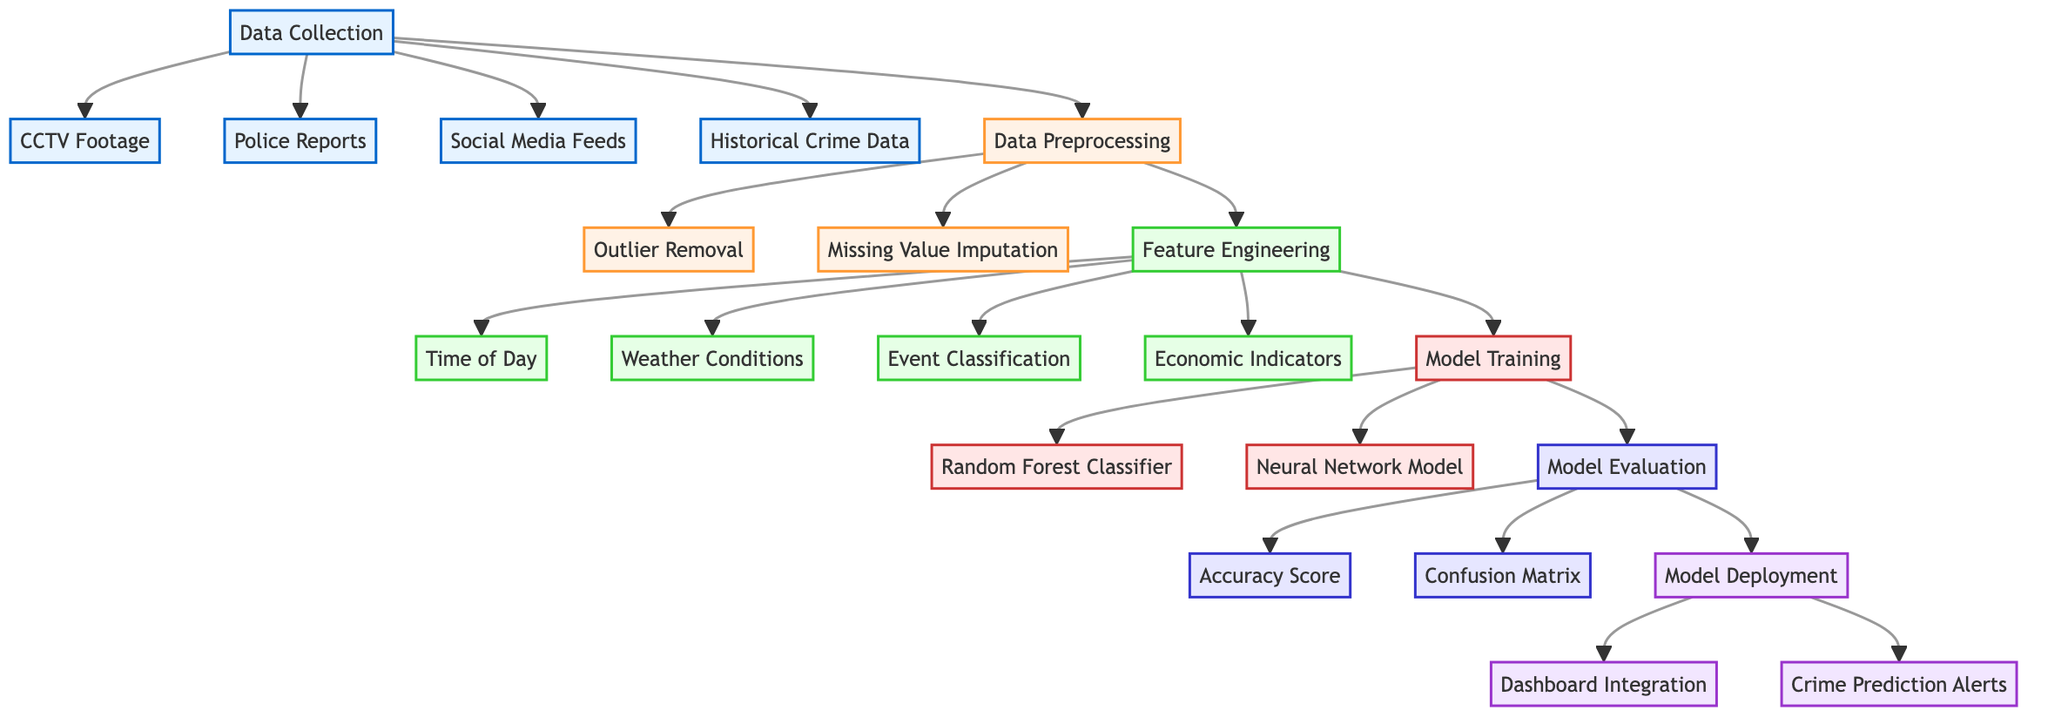What's the first node in the diagram? The diagram begins with the "Data Collection" node, which serves as the starting point for the entire process of predictive analysis.
Answer: Data Collection How many types of data are collected? There are four types of data being collected: CCTV Footage, Police Reports, Social Media Feeds, and Historical Crime Data. This information can be derived from the connections stemming from the "Data Collection" node.
Answer: Four What follows the "Data Preprocessing" node? The next steps after "Data Preprocessing" involve "Feature Engineering," which is the subsequent node connected directly to it, indicating that feature extraction comes after preprocessing.
Answer: Feature Engineering Which models are used for training? The diagram indicates that two models are being used for training: "Random Forest Classifier" and "Neural Network Model," as shown in the branching from the "Model Training" node.
Answer: Random Forest Classifier and Neural Network Model What type of alerts are generated after model deployment? The "Crime Prediction Alerts" node shows the output of this phase, indicating that alerts will be generated to inform residents about potential crimes based on the analysis.
Answer: Crime Prediction Alerts What is the purpose of the "Feature Engineering" step? "Feature Engineering" encompasses the process of creating new features from the existing data, such as time of day, weather conditions, and event classification, which are vital for enhancing the model's predictive capabilities.
Answer: Enhance predictive capabilities How many evaluation metrics are mentioned in the diagram? There are two evaluation metrics shown in the diagram: "Accuracy Score" and "Confusion Matrix," both connected under the "Model Evaluation" node, highlighting key metrics for assessing model performance.
Answer: Two In which step are outliers removed? The "Outlier Removal" step is part of the "Data Preprocessing" phase, which is essential for cleaning the data before it is used for further analysis and model training.
Answer: Data Preprocessing What is connected directly after "Model Evaluation"? The next step following "Model Evaluation" is "Model Deployment," signifying that after evaluating the model, deployment into a real-world situation is the next focus.
Answer: Model Deployment 